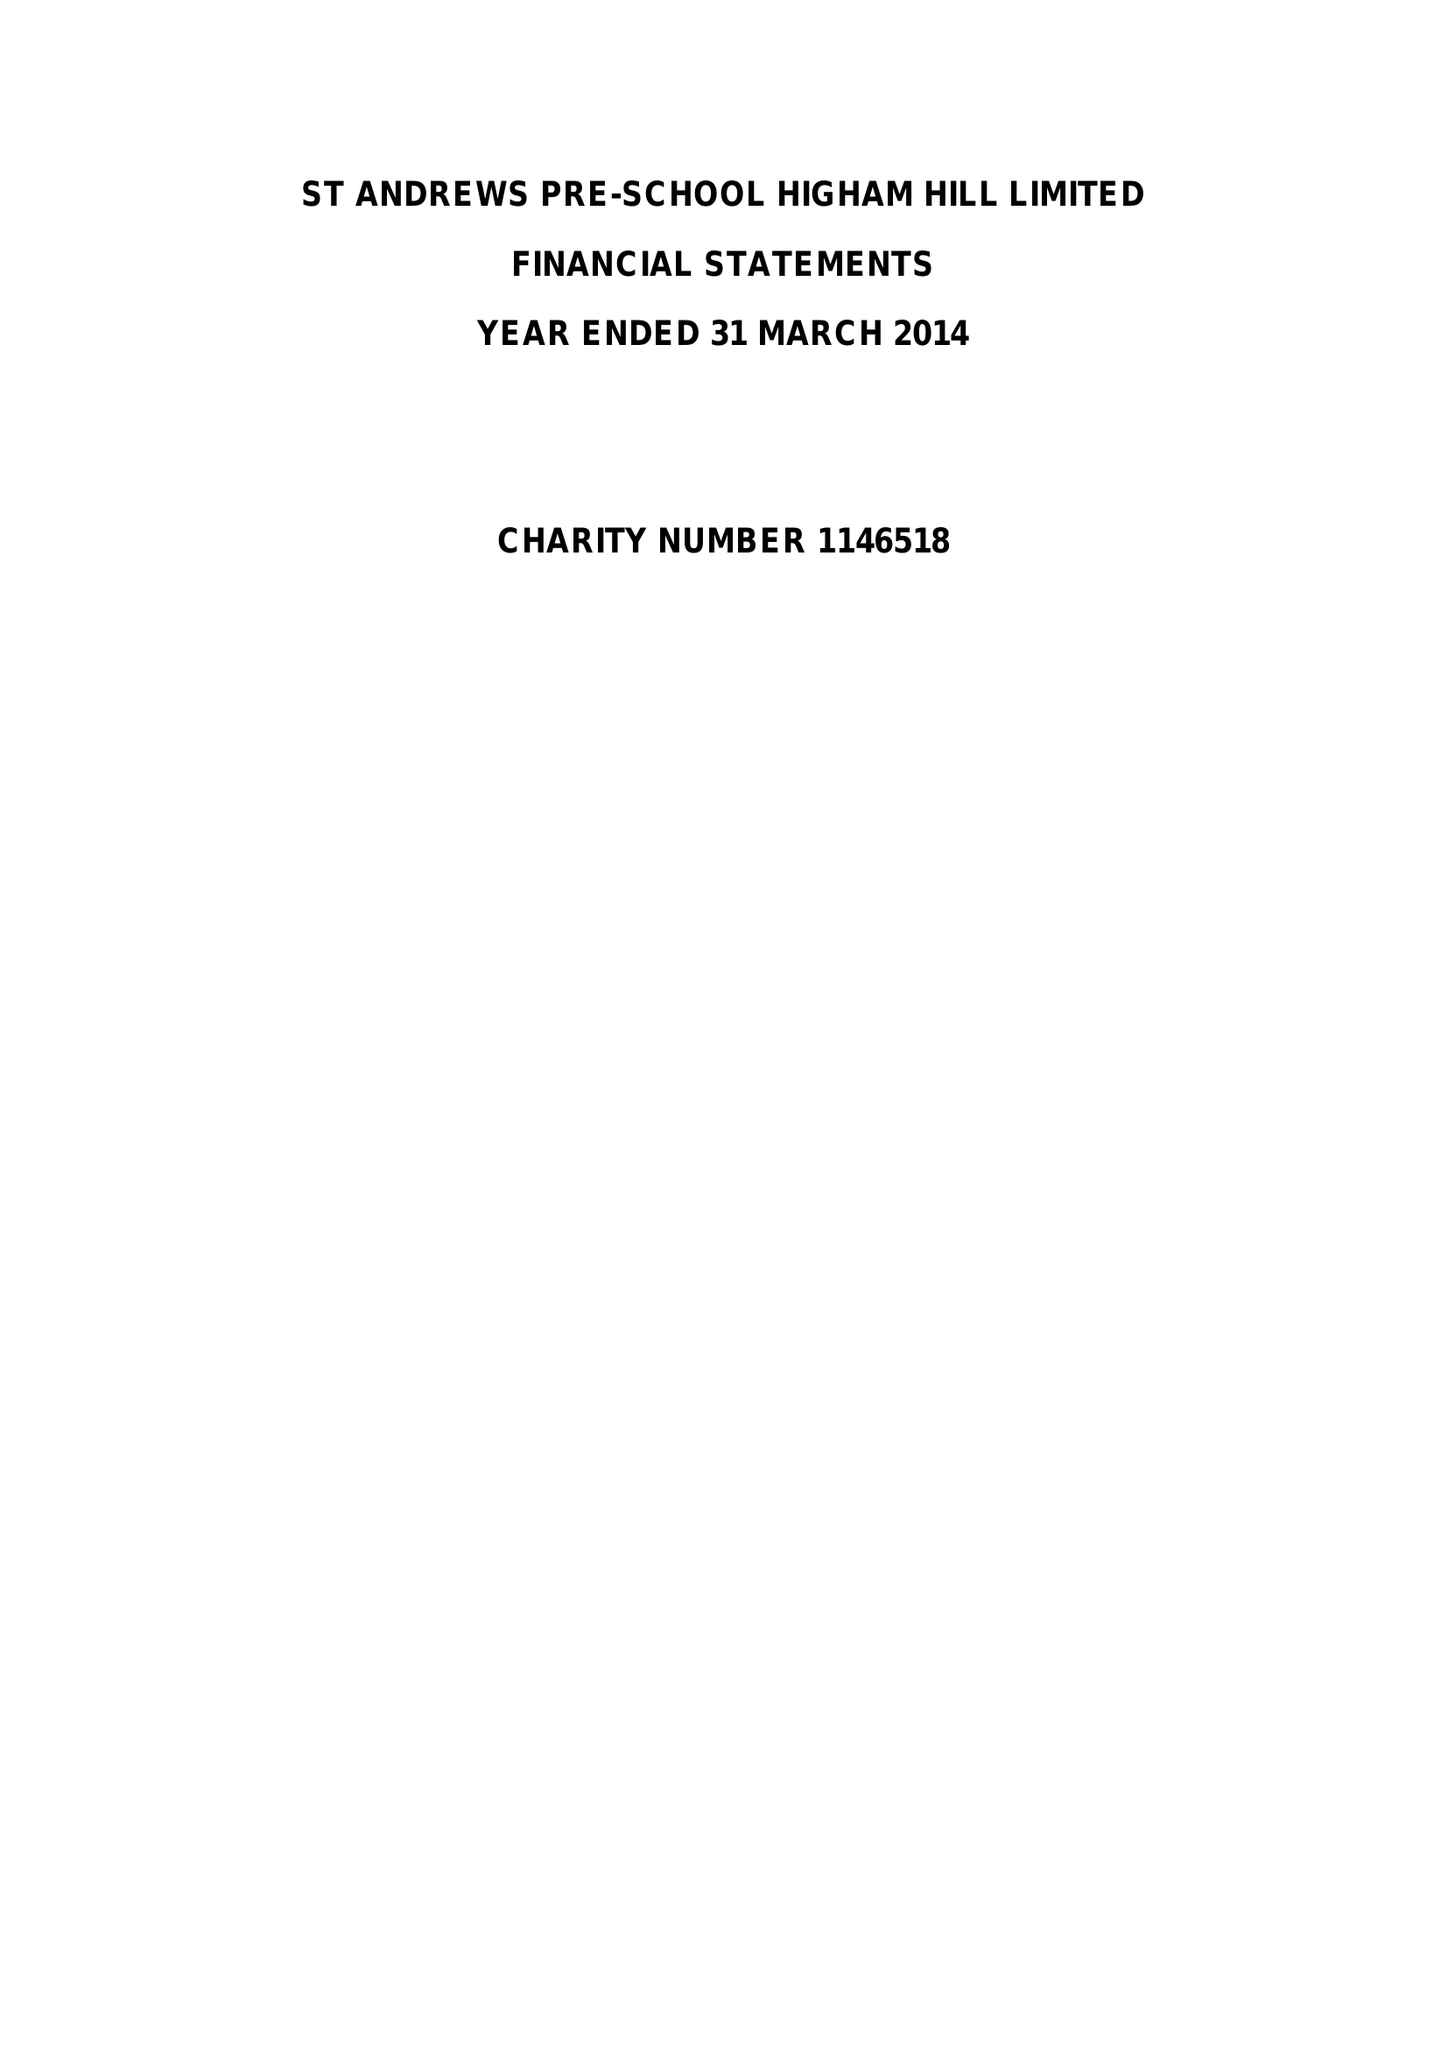What is the value for the income_annually_in_british_pounds?
Answer the question using a single word or phrase. 111016.00 